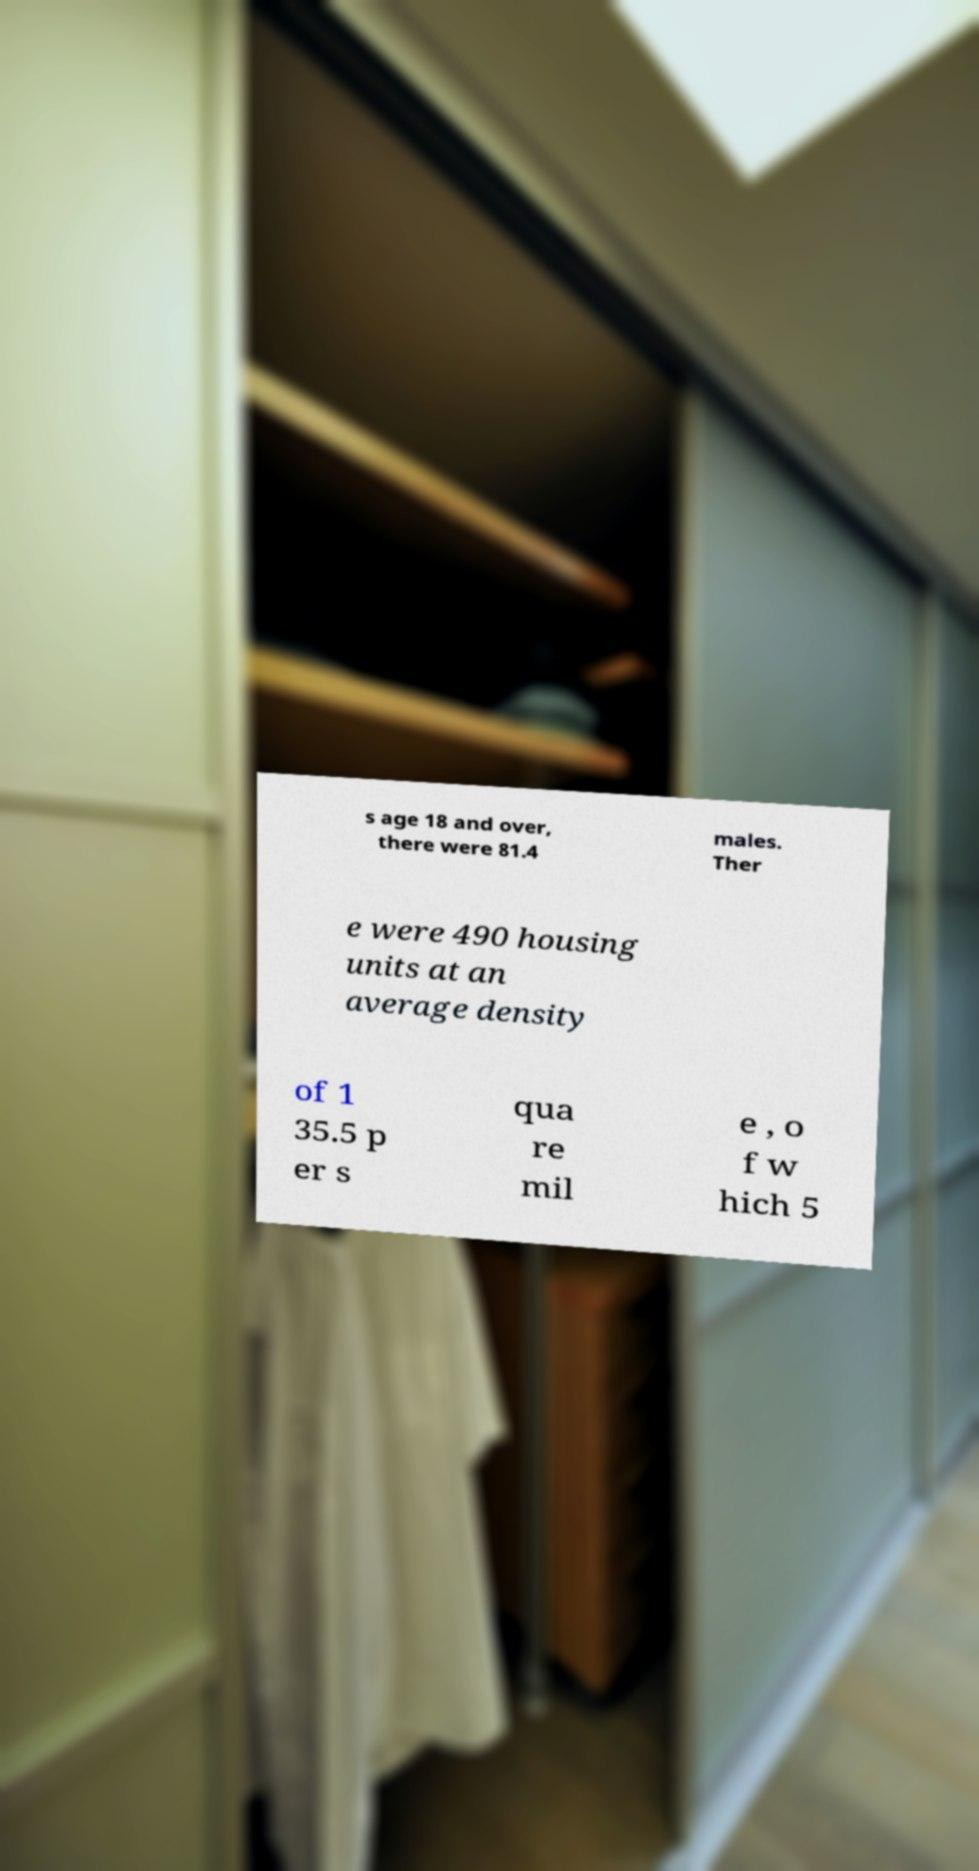Please identify and transcribe the text found in this image. s age 18 and over, there were 81.4 males. Ther e were 490 housing units at an average density of 1 35.5 p er s qua re mil e , o f w hich 5 